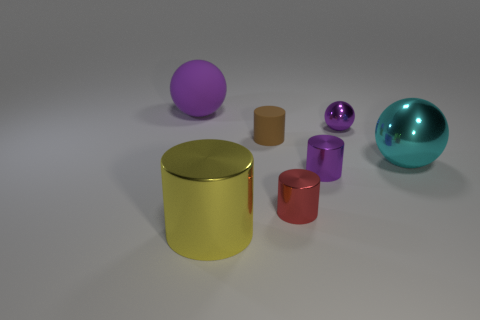What number of brown things are either big rubber cylinders or small matte objects? In the image, there is only one object that can be described as a small matte brown object, which is the small brown cylinder. There are no big rubber cylinders that are brown. 